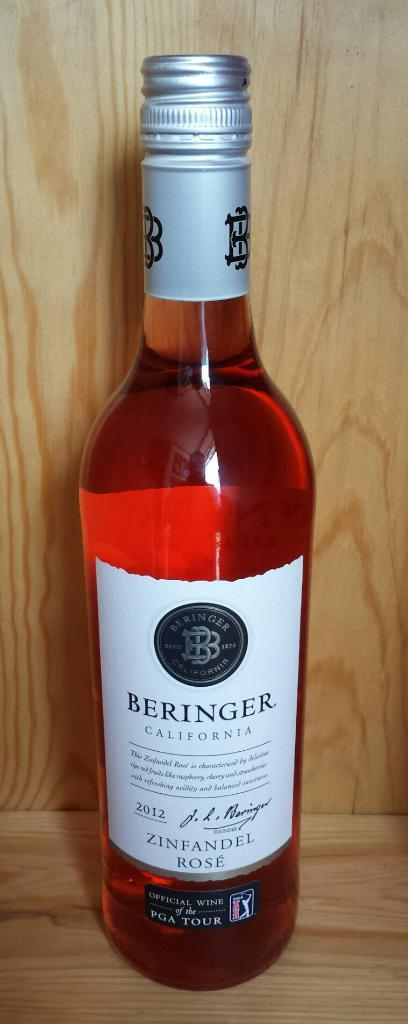<image>
Give a short and clear explanation of the subsequent image. A bottle of red Beringer wine from California. 